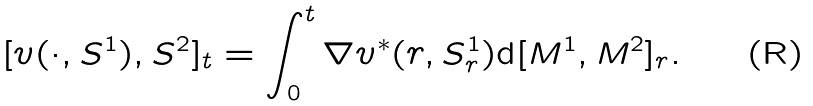<formula> <loc_0><loc_0><loc_500><loc_500>[ v ( \cdot , S ^ { 1 } ) , S ^ { 2 } ] _ { t } = \int _ { 0 } ^ { t } \nabla v ^ { * } ( r , S ^ { 1 } _ { r } ) \mathrm d [ M ^ { 1 } , M ^ { 2 } ] _ { r } .</formula> 